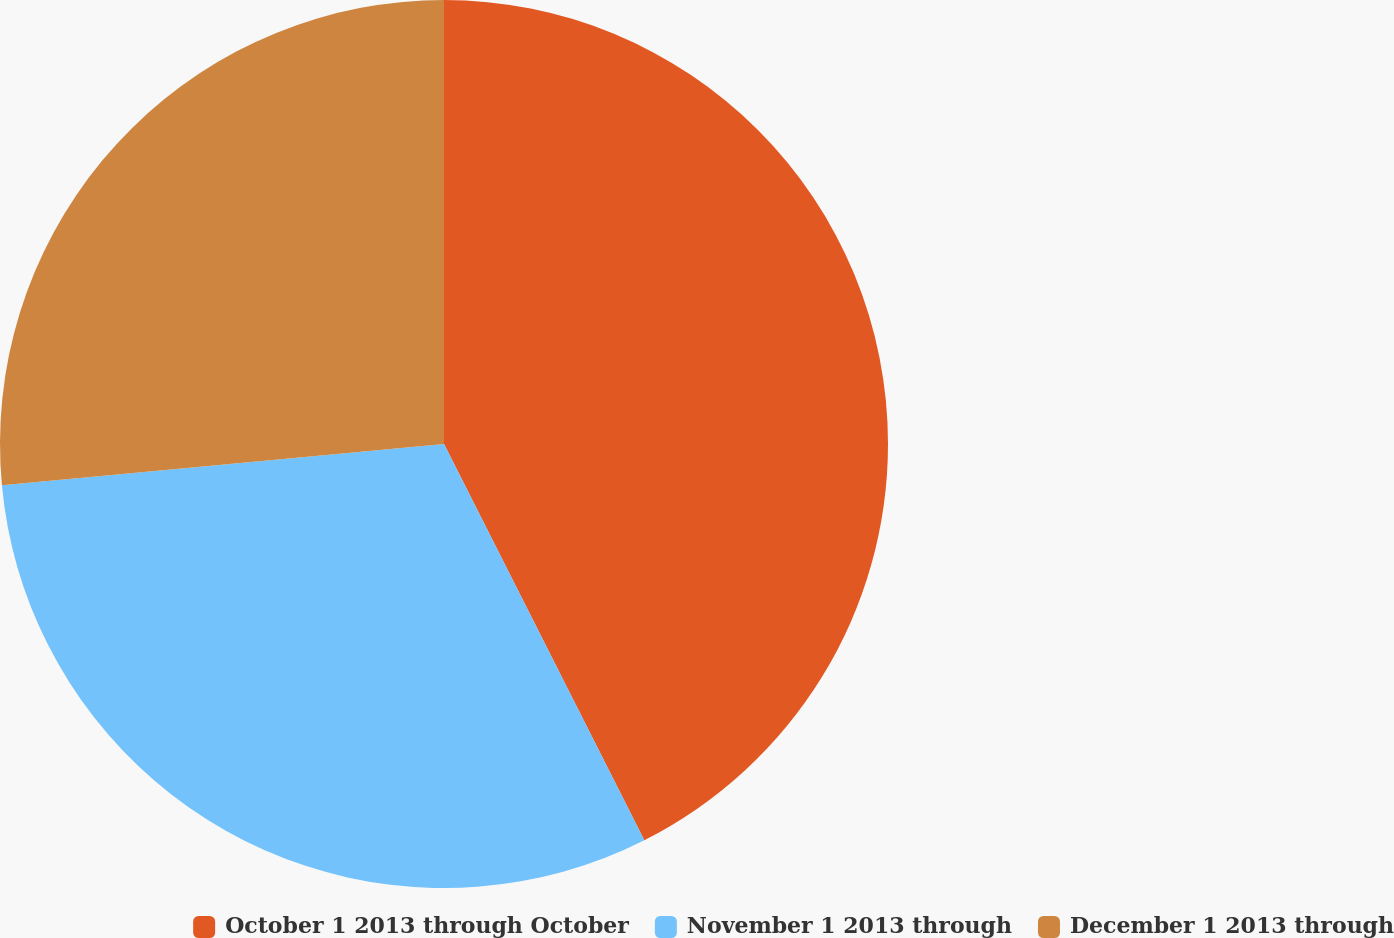<chart> <loc_0><loc_0><loc_500><loc_500><pie_chart><fcel>October 1 2013 through October<fcel>November 1 2013 through<fcel>December 1 2013 through<nl><fcel>42.55%<fcel>30.97%<fcel>26.48%<nl></chart> 